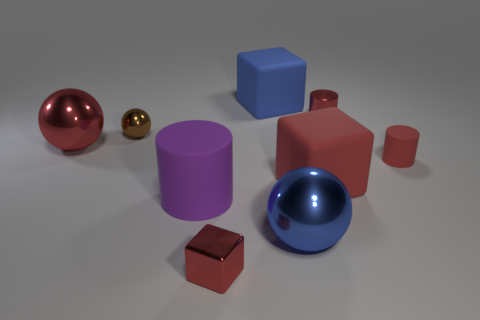Add 1 purple shiny blocks. How many objects exist? 10 Subtract all cylinders. How many objects are left? 6 Subtract 0 yellow blocks. How many objects are left? 9 Subtract all large red shiny cylinders. Subtract all red cubes. How many objects are left? 7 Add 6 blue matte objects. How many blue matte objects are left? 7 Add 4 small yellow shiny blocks. How many small yellow shiny blocks exist? 4 